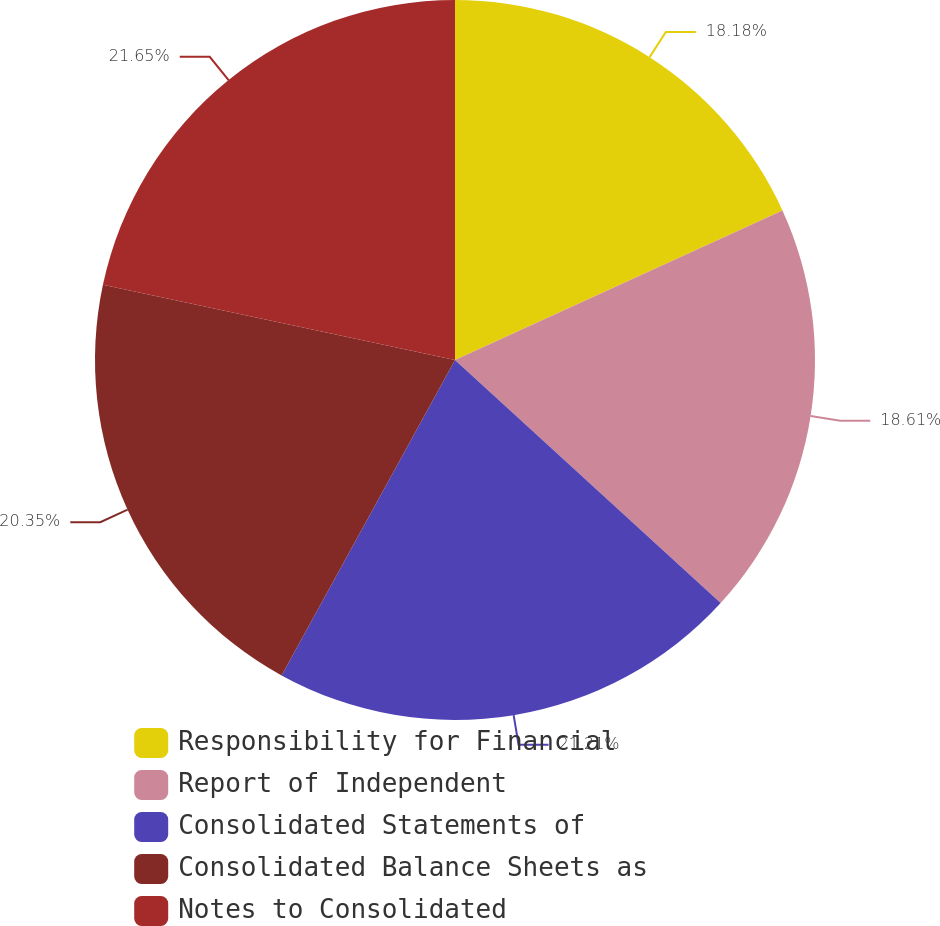Convert chart. <chart><loc_0><loc_0><loc_500><loc_500><pie_chart><fcel>Responsibility for Financial<fcel>Report of Independent<fcel>Consolidated Statements of<fcel>Consolidated Balance Sheets as<fcel>Notes to Consolidated<nl><fcel>18.18%<fcel>18.61%<fcel>21.21%<fcel>20.35%<fcel>21.65%<nl></chart> 